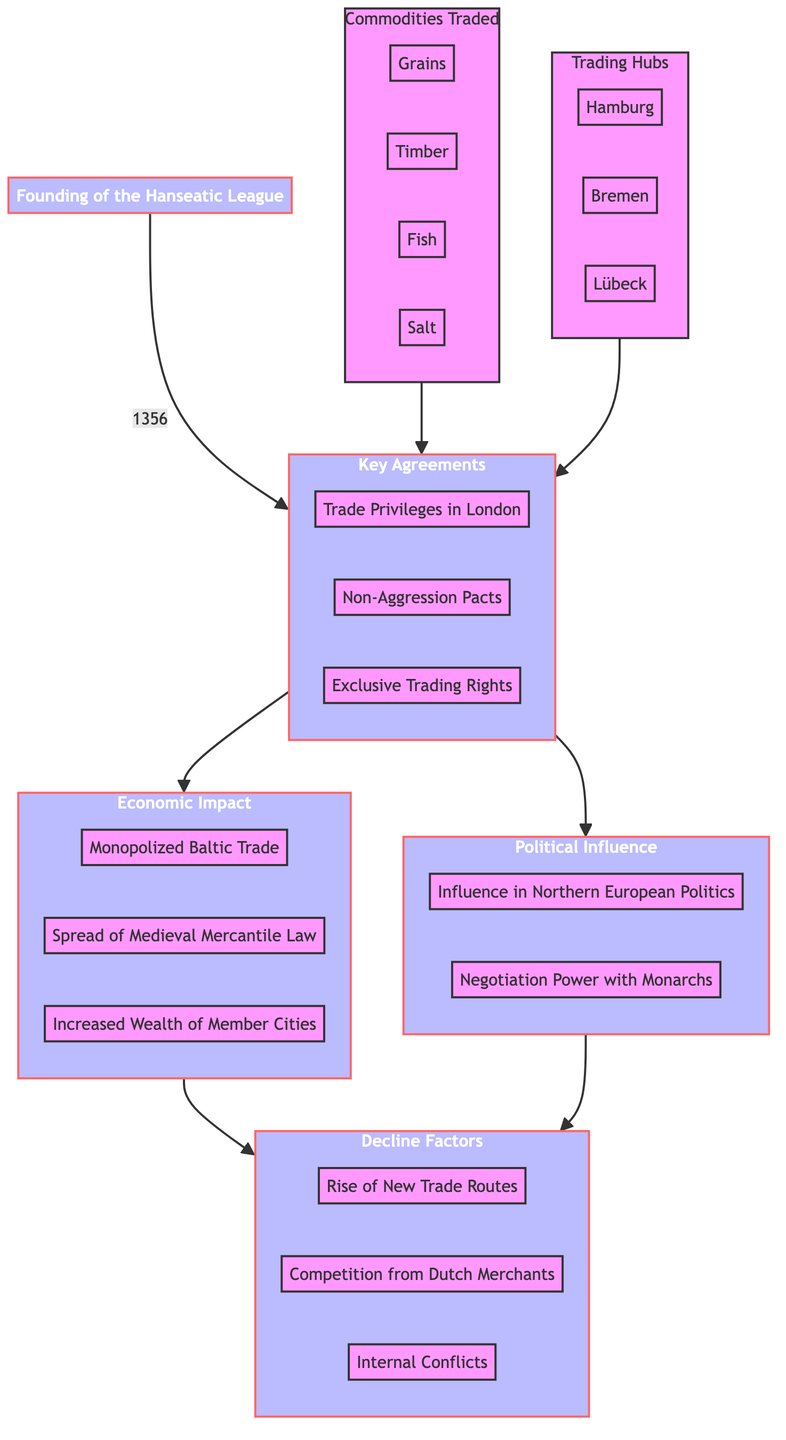What's the founding year of the Hanseatic League? The diagram specifies that the founding of the Hanseatic League occurred in 1356, which is directly indicated near the node labeled “Founding of the Hanseatic League.”
Answer: 1356 Which three trading hubs are mentioned? The diagram shows a subgraph for “Trading Hubs” that includes Hamburg, Bremen, and Lübeck, clearly denoting these three locations as the hubs.
Answer: Hamburg, Bremen, Lübeck What are the key agreements made by the Hanseatic League? The node labeled “Key Agreements” points to three agreements: Trade Privileges in London, Non-Aggression Pacts, and Exclusive Trading Rights are the agreements listed.
Answer: Trade Privileges in London, Non-Aggression Pacts, Exclusive Trading Rights How did the Hanseatic League influence political matters? The diagram identifies “Political Influence” indicating two aspects: Influence in Northern European Politics and Negotiation Power with Monarchs, thus showing its political impact.
Answer: Influence in Northern European Politics, Negotiation Power with Monarchs What is one economic impact of the Hanseatic League? Within the “Economic Impact” node, several outcomes are detailed: Monopolized Baltic Trade, Spread of Medieval Mercantile Law, and Increased Wealth of Member Cities. One example is Monopolized Baltic Trade, which directly shows its economic significance.
Answer: Monopolized Baltic Trade What leads to the decline of the Hanseatic League? The “Decline Factors” node indicates three reasons: Rise of New Trade Routes, Competition from Dutch Merchants, and Internal Conflicts. Each of these factors collectively explains the decline.
Answer: Rise of New Trade Routes, Competition from Dutch Merchants, Internal Conflicts How are trading hubs connected to key agreements? Trading hubs (Hamburg, Bremen, Lübeck) connect to “Key Agreements” as they are shown in the flow towards it, indicating that these locations contributed to forming the agreements that impacted trade.
Answer: Trading Hubs to Key Agreements Which node serves as the starting point for the diagram? The starting point of the flowchart, or the base of the flow, is the “Founding of the Hanseatic League,” which is indicated to lead upward towards the subsequent nodes on key agreements and impacts.
Answer: Founding of the Hanseatic League 